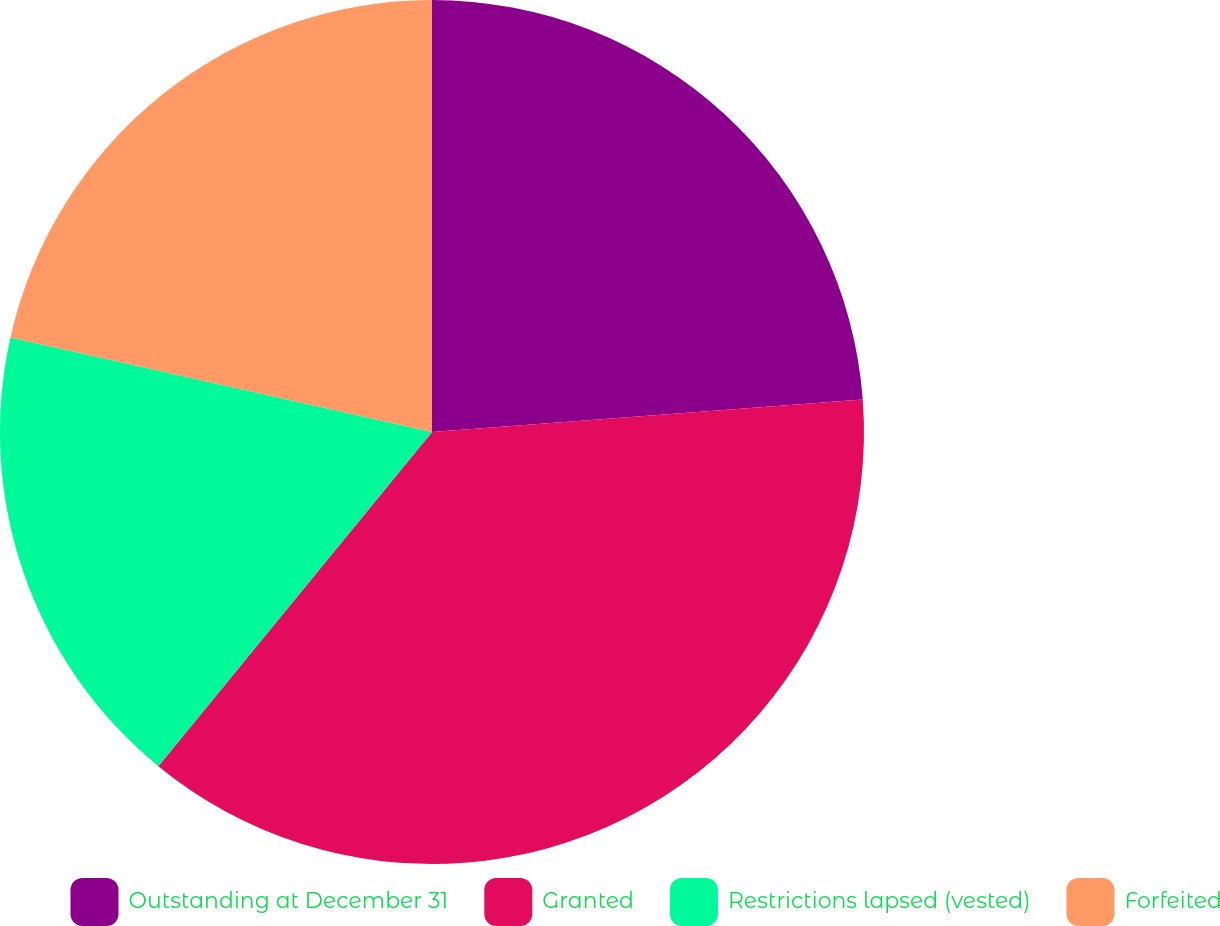<chart> <loc_0><loc_0><loc_500><loc_500><pie_chart><fcel>Outstanding at December 31<fcel>Granted<fcel>Restrictions lapsed (vested)<fcel>Forfeited<nl><fcel>23.8%<fcel>37.12%<fcel>17.59%<fcel>21.49%<nl></chart> 